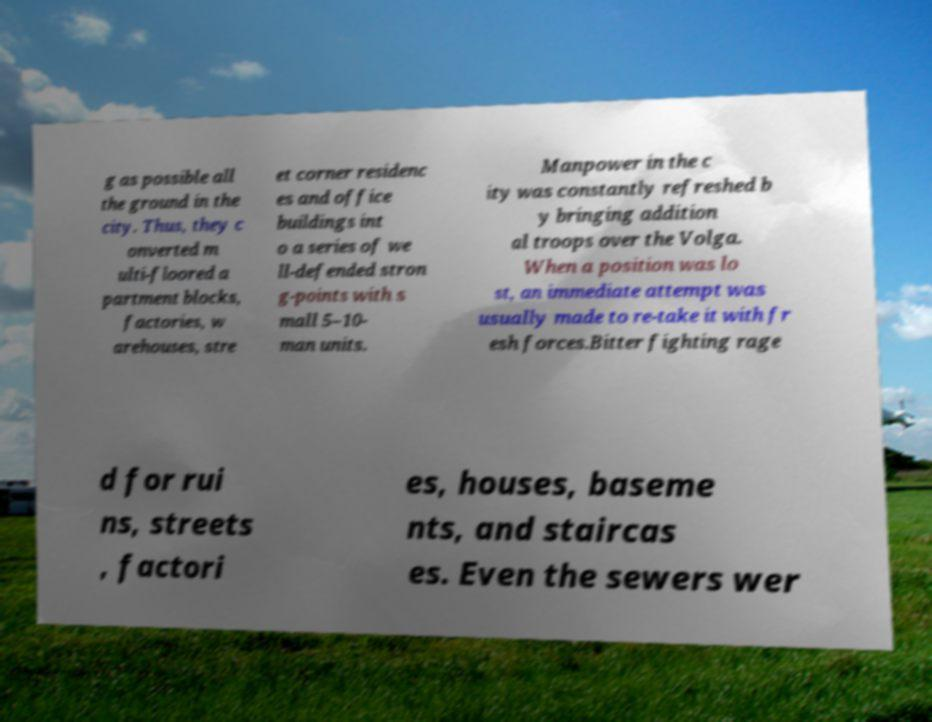Can you read and provide the text displayed in the image?This photo seems to have some interesting text. Can you extract and type it out for me? g as possible all the ground in the city. Thus, they c onverted m ulti-floored a partment blocks, factories, w arehouses, stre et corner residenc es and office buildings int o a series of we ll-defended stron g-points with s mall 5–10- man units. Manpower in the c ity was constantly refreshed b y bringing addition al troops over the Volga. When a position was lo st, an immediate attempt was usually made to re-take it with fr esh forces.Bitter fighting rage d for rui ns, streets , factori es, houses, baseme nts, and staircas es. Even the sewers wer 